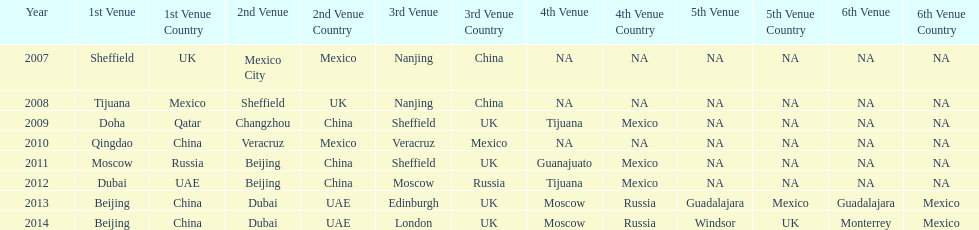Would you mind parsing the complete table? {'header': ['Year', '1st Venue', '1st Venue Country', '2nd Venue', '2nd Venue Country', '3rd Venue', '3rd Venue Country', '4th Venue', '4th Venue Country', '5th Venue', '5th Venue Country', '6th Venue', '6th Venue Country'], 'rows': [['2007', 'Sheffield', 'UK', 'Mexico City', 'Mexico', 'Nanjing', 'China', 'NA', 'NA', 'NA', 'NA', 'NA', 'NA'], ['2008', 'Tijuana', 'Mexico', 'Sheffield', 'UK', 'Nanjing', 'China', 'NA', 'NA', 'NA', 'NA', 'NA', 'NA'], ['2009', 'Doha', 'Qatar', 'Changzhou', 'China', 'Sheffield', 'UK', 'Tijuana', 'Mexico', 'NA', 'NA', 'NA', 'NA'], ['2010', 'Qingdao', 'China', 'Veracruz', 'Mexico', 'Veracruz', 'Mexico', 'NA', 'NA', 'NA', 'NA', 'NA', 'NA'], ['2011', 'Moscow', 'Russia', 'Beijing', 'China', 'Sheffield', 'UK', 'Guanajuato', 'Mexico', 'NA', 'NA', 'NA', 'NA'], ['2012', 'Dubai', 'UAE', 'Beijing', 'China', 'Moscow', 'Russia', 'Tijuana', 'Mexico', 'NA', 'NA', 'NA', 'NA'], ['2013', 'Beijing', 'China', 'Dubai', 'UAE', 'Edinburgh', 'UK', 'Moscow', 'Russia', 'Guadalajara', 'Mexico', 'Guadalajara', 'Mexico'], ['2014', 'Beijing', 'China', 'Dubai', 'UAE', 'London', 'UK', 'Moscow', 'Russia', 'Windsor', 'UK', 'Monterrey', 'Mexico']]} Which is the only year that mexico is on a venue 2007. 